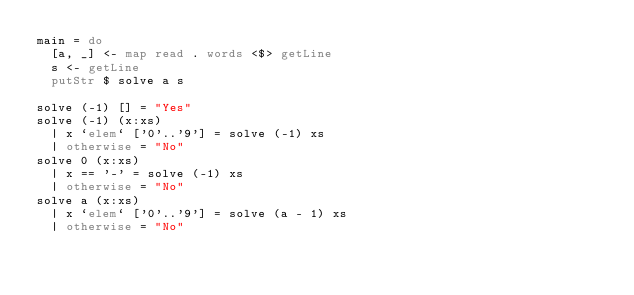<code> <loc_0><loc_0><loc_500><loc_500><_Haskell_>main = do
  [a, _] <- map read . words <$> getLine
  s <- getLine
  putStr $ solve a s

solve (-1) [] = "Yes"
solve (-1) (x:xs)
  | x `elem` ['0'..'9'] = solve (-1) xs
  | otherwise = "No"
solve 0 (x:xs)
  | x == '-' = solve (-1) xs
  | otherwise = "No"
solve a (x:xs)
  | x `elem` ['0'..'9'] = solve (a - 1) xs
  | otherwise = "No"
</code> 